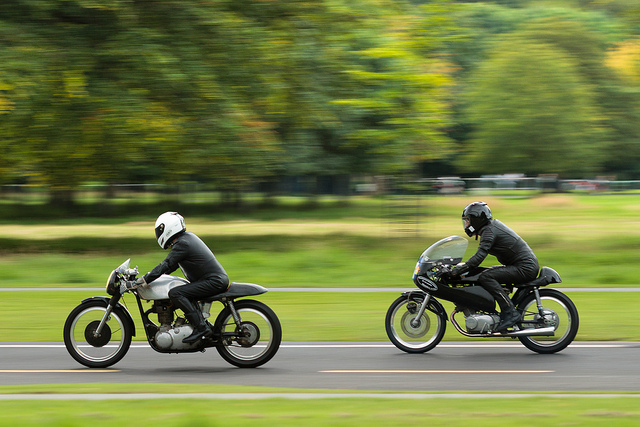How many people can you see? There are exactly two people visible in the image, both riding classic-style motorcycles at speed, giving an impression of a dynamic race or a friendly chase. 